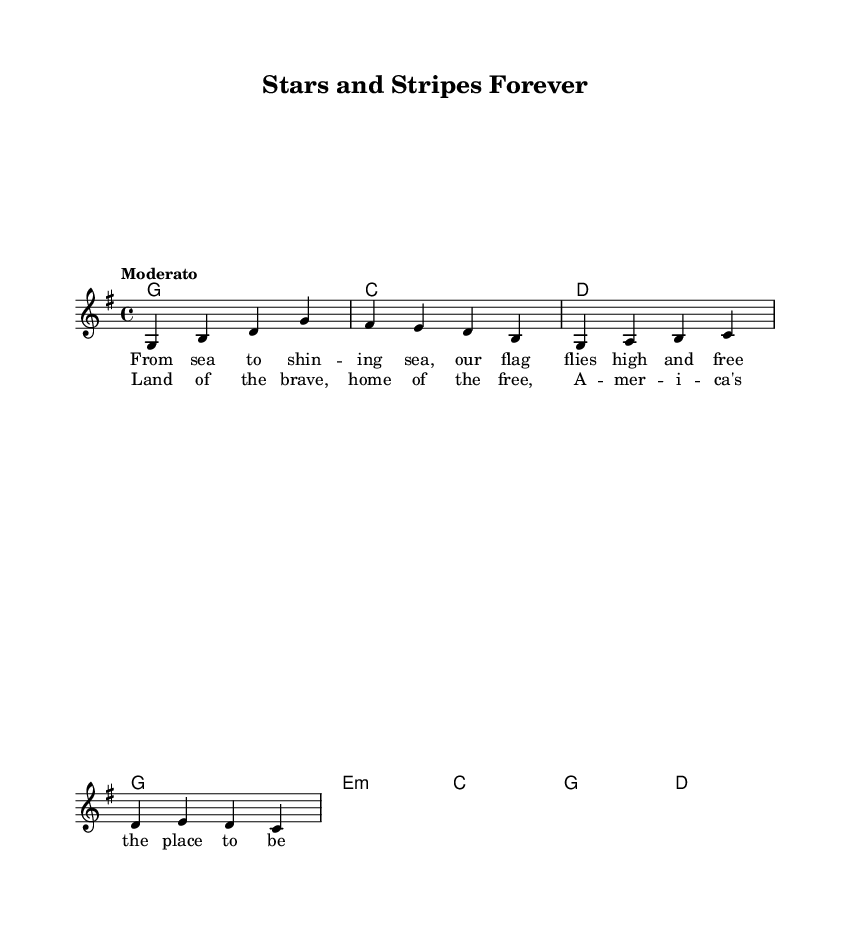What is the key signature of this music? The key signature is G major, which has one sharp (F sharp).
Answer: G major What is the time signature of this music? The time signature displayed is 4/4, which means there are four beats in each measure with each beat being a quarter note.
Answer: 4/4 What is the tempo marking for this piece? The tempo marking is "Moderato," which indicates a moderate pace.
Answer: Moderato How many measures are in the melody? The melody consists of four measures, as counted from the notated music.
Answer: Four What chords are used in the first four measures? The chords used are G, C, D, and G, as indicated in the chord section above the melody.
Answer: G, C, D, G What is the main theme expressed in the lyrics? The lyrics celebrate American heritage, expressing patriotic sentiments about the country.
Answer: American heritage How does this piece reflect the characteristics of Country Rock? The piece combines traditional elements of country music with a rock instrumentation style and patriotic themes common in Country Rock.
Answer: Patriotic themes 